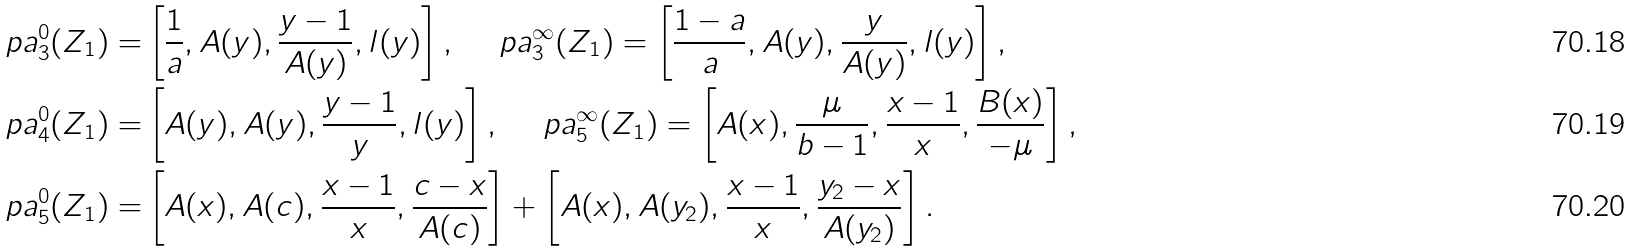Convert formula to latex. <formula><loc_0><loc_0><loc_500><loc_500>\ p a _ { 3 } ^ { 0 } ( Z _ { 1 } ) = & \left [ \frac { 1 } { a } , A ( y ) , \frac { y - 1 } { A ( y ) } , l ( y ) \right ] , \quad \ p a _ { 3 } ^ { \infty } ( Z _ { 1 } ) = \left [ \frac { 1 - a } { a } , A ( y ) , \frac { y } { A ( y ) } , l ( y ) \right ] , \\ \ p a _ { 4 } ^ { 0 } ( Z _ { 1 } ) = & \left [ A ( y ) , A ( y ) , \frac { y - 1 } { y } , l ( y ) \right ] , \quad \ p a _ { 5 } ^ { \infty } ( Z _ { 1 } ) = \left [ A ( x ) , \frac { \mu } { b - 1 } , \frac { x - 1 } { x } , \frac { B ( x ) } { - \mu } \right ] , \\ \ p a _ { 5 } ^ { 0 } ( Z _ { 1 } ) = & \left [ A ( x ) , A ( c ) , \frac { x - 1 } { x } , \frac { c - x } { A ( c ) } \right ] + \left [ A ( x ) , A ( y _ { 2 } ) , \frac { x - 1 } { x } , \frac { y _ { 2 } - x } { A ( y _ { 2 } ) } \right ] .</formula> 